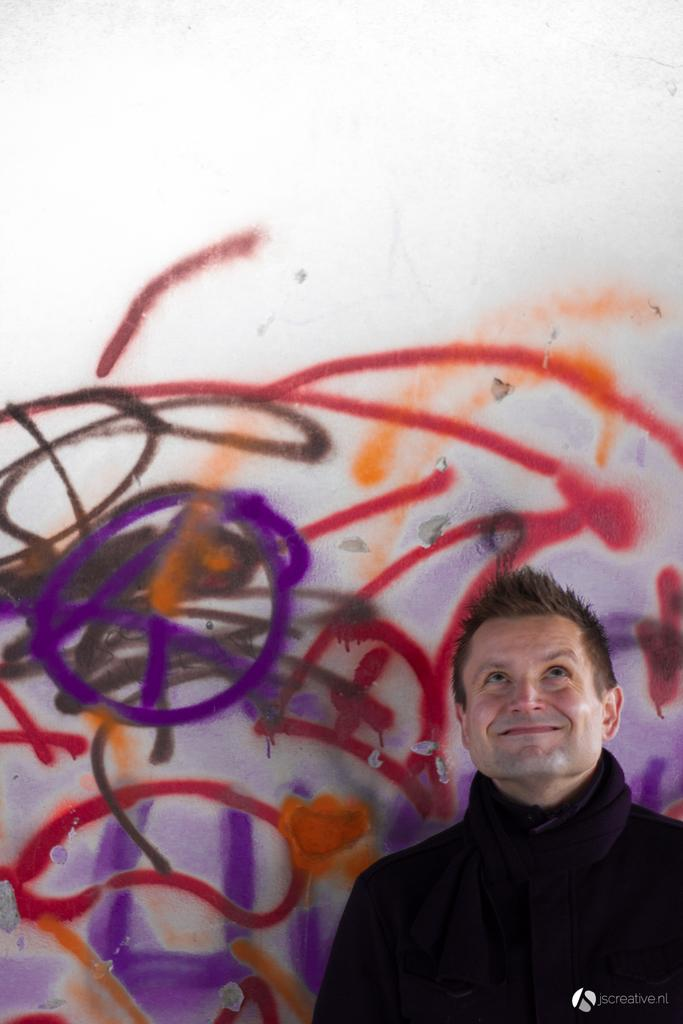What is the main subject in the foreground of the image? There is a man standing in the foreground of the image. What can be seen in the background of the image? There are paintings on the wall in the background of the image. What color is the man's suit in the image? There is no mention of a suit in the provided facts, so we cannot determine the color of the man's suit. 